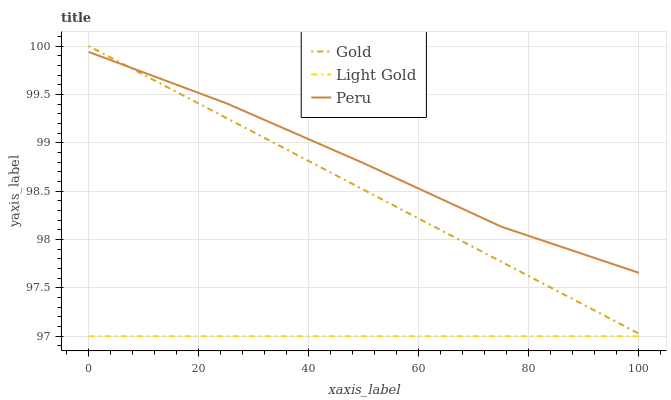Does Light Gold have the minimum area under the curve?
Answer yes or no. Yes. Does Peru have the maximum area under the curve?
Answer yes or no. Yes. Does Gold have the minimum area under the curve?
Answer yes or no. No. Does Gold have the maximum area under the curve?
Answer yes or no. No. Is Light Gold the smoothest?
Answer yes or no. Yes. Is Peru the roughest?
Answer yes or no. Yes. Is Peru the smoothest?
Answer yes or no. No. Is Gold the roughest?
Answer yes or no. No. Does Light Gold have the lowest value?
Answer yes or no. Yes. Does Gold have the lowest value?
Answer yes or no. No. Does Gold have the highest value?
Answer yes or no. Yes. Does Peru have the highest value?
Answer yes or no. No. Is Light Gold less than Gold?
Answer yes or no. Yes. Is Gold greater than Light Gold?
Answer yes or no. Yes. Does Peru intersect Gold?
Answer yes or no. Yes. Is Peru less than Gold?
Answer yes or no. No. Is Peru greater than Gold?
Answer yes or no. No. Does Light Gold intersect Gold?
Answer yes or no. No. 